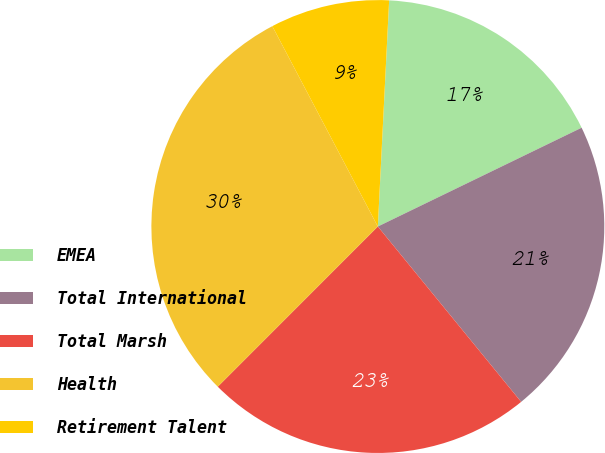Convert chart. <chart><loc_0><loc_0><loc_500><loc_500><pie_chart><fcel>EMEA<fcel>Total International<fcel>Total Marsh<fcel>Health<fcel>Retirement Talent<nl><fcel>17.02%<fcel>21.28%<fcel>23.4%<fcel>29.79%<fcel>8.51%<nl></chart> 